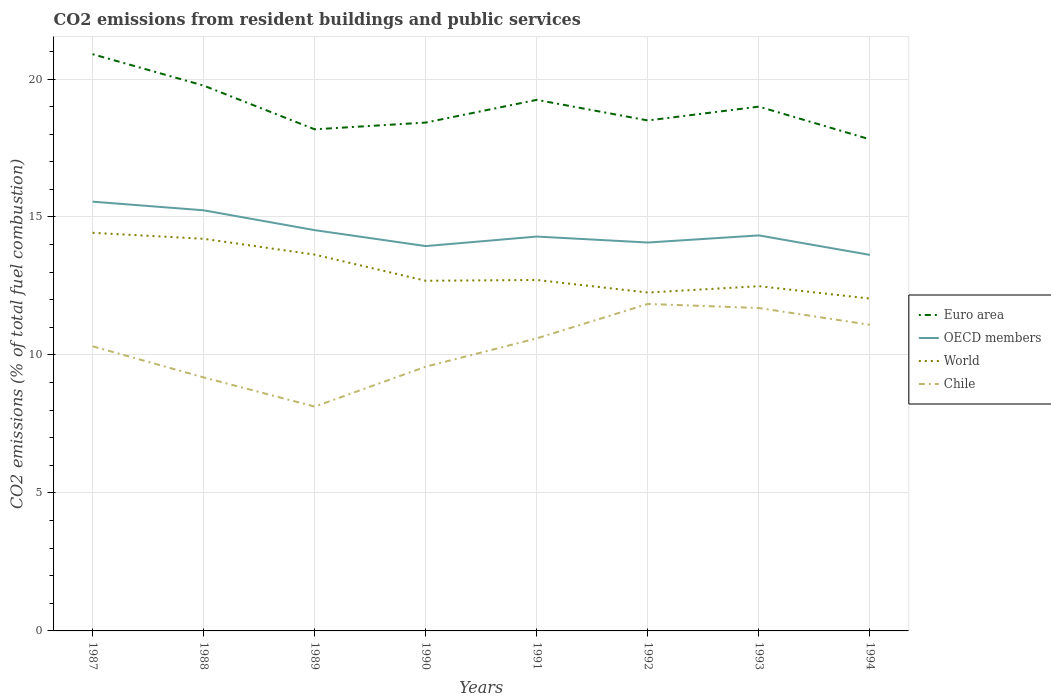How many different coloured lines are there?
Offer a terse response. 4. Does the line corresponding to Chile intersect with the line corresponding to Euro area?
Keep it short and to the point. No. Is the number of lines equal to the number of legend labels?
Your response must be concise. Yes. Across all years, what is the maximum total CO2 emitted in Euro area?
Your answer should be very brief. 17.81. What is the total total CO2 emitted in OECD members in the graph?
Offer a very short reply. -0.39. What is the difference between the highest and the second highest total CO2 emitted in World?
Provide a short and direct response. 2.38. Is the total CO2 emitted in World strictly greater than the total CO2 emitted in Euro area over the years?
Offer a terse response. Yes. How many lines are there?
Give a very brief answer. 4. How many years are there in the graph?
Ensure brevity in your answer.  8. What is the difference between two consecutive major ticks on the Y-axis?
Keep it short and to the point. 5. How many legend labels are there?
Your answer should be very brief. 4. How are the legend labels stacked?
Ensure brevity in your answer.  Vertical. What is the title of the graph?
Offer a very short reply. CO2 emissions from resident buildings and public services. What is the label or title of the X-axis?
Give a very brief answer. Years. What is the label or title of the Y-axis?
Keep it short and to the point. CO2 emissions (% of total fuel combustion). What is the CO2 emissions (% of total fuel combustion) in Euro area in 1987?
Provide a succinct answer. 20.9. What is the CO2 emissions (% of total fuel combustion) of OECD members in 1987?
Provide a short and direct response. 15.56. What is the CO2 emissions (% of total fuel combustion) in World in 1987?
Your answer should be very brief. 14.43. What is the CO2 emissions (% of total fuel combustion) of Chile in 1987?
Your response must be concise. 10.31. What is the CO2 emissions (% of total fuel combustion) in Euro area in 1988?
Provide a succinct answer. 19.76. What is the CO2 emissions (% of total fuel combustion) in OECD members in 1988?
Your answer should be very brief. 15.24. What is the CO2 emissions (% of total fuel combustion) in World in 1988?
Your response must be concise. 14.21. What is the CO2 emissions (% of total fuel combustion) of Chile in 1988?
Keep it short and to the point. 9.19. What is the CO2 emissions (% of total fuel combustion) in Euro area in 1989?
Make the answer very short. 18.18. What is the CO2 emissions (% of total fuel combustion) of OECD members in 1989?
Ensure brevity in your answer.  14.52. What is the CO2 emissions (% of total fuel combustion) in World in 1989?
Keep it short and to the point. 13.64. What is the CO2 emissions (% of total fuel combustion) of Chile in 1989?
Provide a succinct answer. 8.13. What is the CO2 emissions (% of total fuel combustion) in Euro area in 1990?
Provide a short and direct response. 18.42. What is the CO2 emissions (% of total fuel combustion) of OECD members in 1990?
Give a very brief answer. 13.95. What is the CO2 emissions (% of total fuel combustion) of World in 1990?
Your response must be concise. 12.69. What is the CO2 emissions (% of total fuel combustion) in Chile in 1990?
Offer a terse response. 9.57. What is the CO2 emissions (% of total fuel combustion) in Euro area in 1991?
Give a very brief answer. 19.24. What is the CO2 emissions (% of total fuel combustion) in OECD members in 1991?
Keep it short and to the point. 14.29. What is the CO2 emissions (% of total fuel combustion) of World in 1991?
Provide a succinct answer. 12.72. What is the CO2 emissions (% of total fuel combustion) in Chile in 1991?
Ensure brevity in your answer.  10.6. What is the CO2 emissions (% of total fuel combustion) in Euro area in 1992?
Provide a succinct answer. 18.5. What is the CO2 emissions (% of total fuel combustion) in OECD members in 1992?
Your answer should be compact. 14.07. What is the CO2 emissions (% of total fuel combustion) of World in 1992?
Your answer should be compact. 12.26. What is the CO2 emissions (% of total fuel combustion) in Chile in 1992?
Offer a terse response. 11.85. What is the CO2 emissions (% of total fuel combustion) in Euro area in 1993?
Ensure brevity in your answer.  19. What is the CO2 emissions (% of total fuel combustion) in OECD members in 1993?
Provide a succinct answer. 14.33. What is the CO2 emissions (% of total fuel combustion) of World in 1993?
Offer a terse response. 12.49. What is the CO2 emissions (% of total fuel combustion) in Chile in 1993?
Provide a short and direct response. 11.7. What is the CO2 emissions (% of total fuel combustion) in Euro area in 1994?
Give a very brief answer. 17.81. What is the CO2 emissions (% of total fuel combustion) of OECD members in 1994?
Your answer should be very brief. 13.63. What is the CO2 emissions (% of total fuel combustion) in World in 1994?
Provide a succinct answer. 12.04. What is the CO2 emissions (% of total fuel combustion) in Chile in 1994?
Make the answer very short. 11.09. Across all years, what is the maximum CO2 emissions (% of total fuel combustion) in Euro area?
Provide a succinct answer. 20.9. Across all years, what is the maximum CO2 emissions (% of total fuel combustion) of OECD members?
Provide a succinct answer. 15.56. Across all years, what is the maximum CO2 emissions (% of total fuel combustion) in World?
Provide a succinct answer. 14.43. Across all years, what is the maximum CO2 emissions (% of total fuel combustion) in Chile?
Ensure brevity in your answer.  11.85. Across all years, what is the minimum CO2 emissions (% of total fuel combustion) in Euro area?
Offer a very short reply. 17.81. Across all years, what is the minimum CO2 emissions (% of total fuel combustion) of OECD members?
Offer a very short reply. 13.63. Across all years, what is the minimum CO2 emissions (% of total fuel combustion) of World?
Provide a short and direct response. 12.04. Across all years, what is the minimum CO2 emissions (% of total fuel combustion) of Chile?
Your response must be concise. 8.13. What is the total CO2 emissions (% of total fuel combustion) in Euro area in the graph?
Give a very brief answer. 151.81. What is the total CO2 emissions (% of total fuel combustion) of OECD members in the graph?
Your response must be concise. 115.59. What is the total CO2 emissions (% of total fuel combustion) in World in the graph?
Ensure brevity in your answer.  104.48. What is the total CO2 emissions (% of total fuel combustion) in Chile in the graph?
Keep it short and to the point. 82.45. What is the difference between the CO2 emissions (% of total fuel combustion) in Euro area in 1987 and that in 1988?
Offer a very short reply. 1.14. What is the difference between the CO2 emissions (% of total fuel combustion) of OECD members in 1987 and that in 1988?
Offer a very short reply. 0.31. What is the difference between the CO2 emissions (% of total fuel combustion) in World in 1987 and that in 1988?
Provide a succinct answer. 0.22. What is the difference between the CO2 emissions (% of total fuel combustion) in Chile in 1987 and that in 1988?
Offer a very short reply. 1.13. What is the difference between the CO2 emissions (% of total fuel combustion) in Euro area in 1987 and that in 1989?
Your answer should be very brief. 2.72. What is the difference between the CO2 emissions (% of total fuel combustion) in OECD members in 1987 and that in 1989?
Give a very brief answer. 1.03. What is the difference between the CO2 emissions (% of total fuel combustion) in World in 1987 and that in 1989?
Keep it short and to the point. 0.79. What is the difference between the CO2 emissions (% of total fuel combustion) of Chile in 1987 and that in 1989?
Provide a short and direct response. 2.19. What is the difference between the CO2 emissions (% of total fuel combustion) in Euro area in 1987 and that in 1990?
Your answer should be very brief. 2.48. What is the difference between the CO2 emissions (% of total fuel combustion) of OECD members in 1987 and that in 1990?
Offer a very short reply. 1.61. What is the difference between the CO2 emissions (% of total fuel combustion) in World in 1987 and that in 1990?
Your response must be concise. 1.74. What is the difference between the CO2 emissions (% of total fuel combustion) of Chile in 1987 and that in 1990?
Your response must be concise. 0.74. What is the difference between the CO2 emissions (% of total fuel combustion) in Euro area in 1987 and that in 1991?
Your response must be concise. 1.65. What is the difference between the CO2 emissions (% of total fuel combustion) of OECD members in 1987 and that in 1991?
Provide a succinct answer. 1.26. What is the difference between the CO2 emissions (% of total fuel combustion) in World in 1987 and that in 1991?
Your response must be concise. 1.71. What is the difference between the CO2 emissions (% of total fuel combustion) of Chile in 1987 and that in 1991?
Your answer should be compact. -0.29. What is the difference between the CO2 emissions (% of total fuel combustion) of Euro area in 1987 and that in 1992?
Give a very brief answer. 2.4. What is the difference between the CO2 emissions (% of total fuel combustion) of OECD members in 1987 and that in 1992?
Ensure brevity in your answer.  1.48. What is the difference between the CO2 emissions (% of total fuel combustion) of World in 1987 and that in 1992?
Provide a short and direct response. 2.16. What is the difference between the CO2 emissions (% of total fuel combustion) of Chile in 1987 and that in 1992?
Make the answer very short. -1.53. What is the difference between the CO2 emissions (% of total fuel combustion) in Euro area in 1987 and that in 1993?
Provide a short and direct response. 1.9. What is the difference between the CO2 emissions (% of total fuel combustion) in OECD members in 1987 and that in 1993?
Offer a very short reply. 1.22. What is the difference between the CO2 emissions (% of total fuel combustion) of World in 1987 and that in 1993?
Your response must be concise. 1.93. What is the difference between the CO2 emissions (% of total fuel combustion) of Chile in 1987 and that in 1993?
Your response must be concise. -1.39. What is the difference between the CO2 emissions (% of total fuel combustion) of Euro area in 1987 and that in 1994?
Ensure brevity in your answer.  3.09. What is the difference between the CO2 emissions (% of total fuel combustion) in OECD members in 1987 and that in 1994?
Keep it short and to the point. 1.93. What is the difference between the CO2 emissions (% of total fuel combustion) in World in 1987 and that in 1994?
Ensure brevity in your answer.  2.38. What is the difference between the CO2 emissions (% of total fuel combustion) of Chile in 1987 and that in 1994?
Your answer should be very brief. -0.78. What is the difference between the CO2 emissions (% of total fuel combustion) in Euro area in 1988 and that in 1989?
Give a very brief answer. 1.58. What is the difference between the CO2 emissions (% of total fuel combustion) of OECD members in 1988 and that in 1989?
Provide a succinct answer. 0.72. What is the difference between the CO2 emissions (% of total fuel combustion) of World in 1988 and that in 1989?
Your response must be concise. 0.57. What is the difference between the CO2 emissions (% of total fuel combustion) in Chile in 1988 and that in 1989?
Your response must be concise. 1.06. What is the difference between the CO2 emissions (% of total fuel combustion) of Euro area in 1988 and that in 1990?
Keep it short and to the point. 1.34. What is the difference between the CO2 emissions (% of total fuel combustion) of OECD members in 1988 and that in 1990?
Your answer should be very brief. 1.3. What is the difference between the CO2 emissions (% of total fuel combustion) in World in 1988 and that in 1990?
Give a very brief answer. 1.52. What is the difference between the CO2 emissions (% of total fuel combustion) in Chile in 1988 and that in 1990?
Your answer should be very brief. -0.39. What is the difference between the CO2 emissions (% of total fuel combustion) of Euro area in 1988 and that in 1991?
Offer a very short reply. 0.52. What is the difference between the CO2 emissions (% of total fuel combustion) of OECD members in 1988 and that in 1991?
Make the answer very short. 0.95. What is the difference between the CO2 emissions (% of total fuel combustion) of World in 1988 and that in 1991?
Make the answer very short. 1.49. What is the difference between the CO2 emissions (% of total fuel combustion) of Chile in 1988 and that in 1991?
Provide a succinct answer. -1.42. What is the difference between the CO2 emissions (% of total fuel combustion) of Euro area in 1988 and that in 1992?
Your answer should be compact. 1.26. What is the difference between the CO2 emissions (% of total fuel combustion) of OECD members in 1988 and that in 1992?
Provide a short and direct response. 1.17. What is the difference between the CO2 emissions (% of total fuel combustion) of World in 1988 and that in 1992?
Your answer should be compact. 1.95. What is the difference between the CO2 emissions (% of total fuel combustion) in Chile in 1988 and that in 1992?
Give a very brief answer. -2.66. What is the difference between the CO2 emissions (% of total fuel combustion) of Euro area in 1988 and that in 1993?
Your answer should be very brief. 0.76. What is the difference between the CO2 emissions (% of total fuel combustion) in OECD members in 1988 and that in 1993?
Your response must be concise. 0.91. What is the difference between the CO2 emissions (% of total fuel combustion) of World in 1988 and that in 1993?
Your response must be concise. 1.72. What is the difference between the CO2 emissions (% of total fuel combustion) in Chile in 1988 and that in 1993?
Your answer should be very brief. -2.51. What is the difference between the CO2 emissions (% of total fuel combustion) in Euro area in 1988 and that in 1994?
Offer a very short reply. 1.95. What is the difference between the CO2 emissions (% of total fuel combustion) of OECD members in 1988 and that in 1994?
Your answer should be very brief. 1.62. What is the difference between the CO2 emissions (% of total fuel combustion) of World in 1988 and that in 1994?
Your answer should be compact. 2.17. What is the difference between the CO2 emissions (% of total fuel combustion) in Chile in 1988 and that in 1994?
Your response must be concise. -1.91. What is the difference between the CO2 emissions (% of total fuel combustion) in Euro area in 1989 and that in 1990?
Your answer should be very brief. -0.24. What is the difference between the CO2 emissions (% of total fuel combustion) of OECD members in 1989 and that in 1990?
Make the answer very short. 0.58. What is the difference between the CO2 emissions (% of total fuel combustion) of World in 1989 and that in 1990?
Provide a succinct answer. 0.95. What is the difference between the CO2 emissions (% of total fuel combustion) of Chile in 1989 and that in 1990?
Your answer should be compact. -1.45. What is the difference between the CO2 emissions (% of total fuel combustion) of Euro area in 1989 and that in 1991?
Ensure brevity in your answer.  -1.07. What is the difference between the CO2 emissions (% of total fuel combustion) of OECD members in 1989 and that in 1991?
Make the answer very short. 0.23. What is the difference between the CO2 emissions (% of total fuel combustion) of World in 1989 and that in 1991?
Your response must be concise. 0.92. What is the difference between the CO2 emissions (% of total fuel combustion) of Chile in 1989 and that in 1991?
Provide a short and direct response. -2.47. What is the difference between the CO2 emissions (% of total fuel combustion) of Euro area in 1989 and that in 1992?
Your answer should be very brief. -0.32. What is the difference between the CO2 emissions (% of total fuel combustion) of OECD members in 1989 and that in 1992?
Your response must be concise. 0.45. What is the difference between the CO2 emissions (% of total fuel combustion) in World in 1989 and that in 1992?
Give a very brief answer. 1.37. What is the difference between the CO2 emissions (% of total fuel combustion) in Chile in 1989 and that in 1992?
Provide a succinct answer. -3.72. What is the difference between the CO2 emissions (% of total fuel combustion) of Euro area in 1989 and that in 1993?
Provide a succinct answer. -0.82. What is the difference between the CO2 emissions (% of total fuel combustion) of OECD members in 1989 and that in 1993?
Offer a terse response. 0.19. What is the difference between the CO2 emissions (% of total fuel combustion) in World in 1989 and that in 1993?
Your answer should be compact. 1.14. What is the difference between the CO2 emissions (% of total fuel combustion) in Chile in 1989 and that in 1993?
Provide a succinct answer. -3.57. What is the difference between the CO2 emissions (% of total fuel combustion) of Euro area in 1989 and that in 1994?
Your response must be concise. 0.36. What is the difference between the CO2 emissions (% of total fuel combustion) in OECD members in 1989 and that in 1994?
Provide a succinct answer. 0.9. What is the difference between the CO2 emissions (% of total fuel combustion) in World in 1989 and that in 1994?
Keep it short and to the point. 1.59. What is the difference between the CO2 emissions (% of total fuel combustion) in Chile in 1989 and that in 1994?
Offer a very short reply. -2.96. What is the difference between the CO2 emissions (% of total fuel combustion) in Euro area in 1990 and that in 1991?
Provide a succinct answer. -0.82. What is the difference between the CO2 emissions (% of total fuel combustion) in OECD members in 1990 and that in 1991?
Provide a succinct answer. -0.35. What is the difference between the CO2 emissions (% of total fuel combustion) in World in 1990 and that in 1991?
Offer a terse response. -0.03. What is the difference between the CO2 emissions (% of total fuel combustion) in Chile in 1990 and that in 1991?
Ensure brevity in your answer.  -1.03. What is the difference between the CO2 emissions (% of total fuel combustion) of Euro area in 1990 and that in 1992?
Your answer should be very brief. -0.08. What is the difference between the CO2 emissions (% of total fuel combustion) of OECD members in 1990 and that in 1992?
Ensure brevity in your answer.  -0.13. What is the difference between the CO2 emissions (% of total fuel combustion) in World in 1990 and that in 1992?
Ensure brevity in your answer.  0.43. What is the difference between the CO2 emissions (% of total fuel combustion) in Chile in 1990 and that in 1992?
Keep it short and to the point. -2.27. What is the difference between the CO2 emissions (% of total fuel combustion) of Euro area in 1990 and that in 1993?
Offer a terse response. -0.58. What is the difference between the CO2 emissions (% of total fuel combustion) in OECD members in 1990 and that in 1993?
Ensure brevity in your answer.  -0.39. What is the difference between the CO2 emissions (% of total fuel combustion) in World in 1990 and that in 1993?
Provide a short and direct response. 0.2. What is the difference between the CO2 emissions (% of total fuel combustion) in Chile in 1990 and that in 1993?
Provide a succinct answer. -2.13. What is the difference between the CO2 emissions (% of total fuel combustion) in Euro area in 1990 and that in 1994?
Ensure brevity in your answer.  0.61. What is the difference between the CO2 emissions (% of total fuel combustion) of OECD members in 1990 and that in 1994?
Provide a short and direct response. 0.32. What is the difference between the CO2 emissions (% of total fuel combustion) of World in 1990 and that in 1994?
Your answer should be very brief. 0.64. What is the difference between the CO2 emissions (% of total fuel combustion) in Chile in 1990 and that in 1994?
Offer a terse response. -1.52. What is the difference between the CO2 emissions (% of total fuel combustion) of Euro area in 1991 and that in 1992?
Your response must be concise. 0.75. What is the difference between the CO2 emissions (% of total fuel combustion) in OECD members in 1991 and that in 1992?
Give a very brief answer. 0.22. What is the difference between the CO2 emissions (% of total fuel combustion) of World in 1991 and that in 1992?
Offer a terse response. 0.45. What is the difference between the CO2 emissions (% of total fuel combustion) of Chile in 1991 and that in 1992?
Keep it short and to the point. -1.25. What is the difference between the CO2 emissions (% of total fuel combustion) of Euro area in 1991 and that in 1993?
Keep it short and to the point. 0.24. What is the difference between the CO2 emissions (% of total fuel combustion) in OECD members in 1991 and that in 1993?
Offer a very short reply. -0.04. What is the difference between the CO2 emissions (% of total fuel combustion) in World in 1991 and that in 1993?
Provide a succinct answer. 0.23. What is the difference between the CO2 emissions (% of total fuel combustion) of Chile in 1991 and that in 1993?
Provide a short and direct response. -1.1. What is the difference between the CO2 emissions (% of total fuel combustion) of Euro area in 1991 and that in 1994?
Give a very brief answer. 1.43. What is the difference between the CO2 emissions (% of total fuel combustion) of OECD members in 1991 and that in 1994?
Make the answer very short. 0.66. What is the difference between the CO2 emissions (% of total fuel combustion) of World in 1991 and that in 1994?
Offer a terse response. 0.67. What is the difference between the CO2 emissions (% of total fuel combustion) in Chile in 1991 and that in 1994?
Your answer should be very brief. -0.49. What is the difference between the CO2 emissions (% of total fuel combustion) in Euro area in 1992 and that in 1993?
Offer a very short reply. -0.5. What is the difference between the CO2 emissions (% of total fuel combustion) of OECD members in 1992 and that in 1993?
Your response must be concise. -0.26. What is the difference between the CO2 emissions (% of total fuel combustion) in World in 1992 and that in 1993?
Your answer should be compact. -0.23. What is the difference between the CO2 emissions (% of total fuel combustion) of Chile in 1992 and that in 1993?
Your response must be concise. 0.15. What is the difference between the CO2 emissions (% of total fuel combustion) of Euro area in 1992 and that in 1994?
Make the answer very short. 0.68. What is the difference between the CO2 emissions (% of total fuel combustion) of OECD members in 1992 and that in 1994?
Keep it short and to the point. 0.45. What is the difference between the CO2 emissions (% of total fuel combustion) of World in 1992 and that in 1994?
Your response must be concise. 0.22. What is the difference between the CO2 emissions (% of total fuel combustion) in Chile in 1992 and that in 1994?
Provide a short and direct response. 0.76. What is the difference between the CO2 emissions (% of total fuel combustion) in Euro area in 1993 and that in 1994?
Offer a terse response. 1.19. What is the difference between the CO2 emissions (% of total fuel combustion) in OECD members in 1993 and that in 1994?
Provide a succinct answer. 0.71. What is the difference between the CO2 emissions (% of total fuel combustion) of World in 1993 and that in 1994?
Ensure brevity in your answer.  0.45. What is the difference between the CO2 emissions (% of total fuel combustion) of Chile in 1993 and that in 1994?
Your response must be concise. 0.61. What is the difference between the CO2 emissions (% of total fuel combustion) in Euro area in 1987 and the CO2 emissions (% of total fuel combustion) in OECD members in 1988?
Provide a short and direct response. 5.66. What is the difference between the CO2 emissions (% of total fuel combustion) in Euro area in 1987 and the CO2 emissions (% of total fuel combustion) in World in 1988?
Give a very brief answer. 6.69. What is the difference between the CO2 emissions (% of total fuel combustion) in Euro area in 1987 and the CO2 emissions (% of total fuel combustion) in Chile in 1988?
Your response must be concise. 11.71. What is the difference between the CO2 emissions (% of total fuel combustion) of OECD members in 1987 and the CO2 emissions (% of total fuel combustion) of World in 1988?
Offer a very short reply. 1.35. What is the difference between the CO2 emissions (% of total fuel combustion) of OECD members in 1987 and the CO2 emissions (% of total fuel combustion) of Chile in 1988?
Offer a very short reply. 6.37. What is the difference between the CO2 emissions (% of total fuel combustion) in World in 1987 and the CO2 emissions (% of total fuel combustion) in Chile in 1988?
Your response must be concise. 5.24. What is the difference between the CO2 emissions (% of total fuel combustion) of Euro area in 1987 and the CO2 emissions (% of total fuel combustion) of OECD members in 1989?
Keep it short and to the point. 6.38. What is the difference between the CO2 emissions (% of total fuel combustion) of Euro area in 1987 and the CO2 emissions (% of total fuel combustion) of World in 1989?
Ensure brevity in your answer.  7.26. What is the difference between the CO2 emissions (% of total fuel combustion) in Euro area in 1987 and the CO2 emissions (% of total fuel combustion) in Chile in 1989?
Keep it short and to the point. 12.77. What is the difference between the CO2 emissions (% of total fuel combustion) of OECD members in 1987 and the CO2 emissions (% of total fuel combustion) of World in 1989?
Offer a terse response. 1.92. What is the difference between the CO2 emissions (% of total fuel combustion) in OECD members in 1987 and the CO2 emissions (% of total fuel combustion) in Chile in 1989?
Provide a succinct answer. 7.43. What is the difference between the CO2 emissions (% of total fuel combustion) in World in 1987 and the CO2 emissions (% of total fuel combustion) in Chile in 1989?
Provide a short and direct response. 6.3. What is the difference between the CO2 emissions (% of total fuel combustion) in Euro area in 1987 and the CO2 emissions (% of total fuel combustion) in OECD members in 1990?
Give a very brief answer. 6.95. What is the difference between the CO2 emissions (% of total fuel combustion) of Euro area in 1987 and the CO2 emissions (% of total fuel combustion) of World in 1990?
Provide a succinct answer. 8.21. What is the difference between the CO2 emissions (% of total fuel combustion) of Euro area in 1987 and the CO2 emissions (% of total fuel combustion) of Chile in 1990?
Offer a terse response. 11.32. What is the difference between the CO2 emissions (% of total fuel combustion) of OECD members in 1987 and the CO2 emissions (% of total fuel combustion) of World in 1990?
Provide a succinct answer. 2.87. What is the difference between the CO2 emissions (% of total fuel combustion) in OECD members in 1987 and the CO2 emissions (% of total fuel combustion) in Chile in 1990?
Keep it short and to the point. 5.98. What is the difference between the CO2 emissions (% of total fuel combustion) of World in 1987 and the CO2 emissions (% of total fuel combustion) of Chile in 1990?
Your answer should be very brief. 4.85. What is the difference between the CO2 emissions (% of total fuel combustion) of Euro area in 1987 and the CO2 emissions (% of total fuel combustion) of OECD members in 1991?
Offer a terse response. 6.61. What is the difference between the CO2 emissions (% of total fuel combustion) in Euro area in 1987 and the CO2 emissions (% of total fuel combustion) in World in 1991?
Your answer should be compact. 8.18. What is the difference between the CO2 emissions (% of total fuel combustion) of Euro area in 1987 and the CO2 emissions (% of total fuel combustion) of Chile in 1991?
Provide a succinct answer. 10.3. What is the difference between the CO2 emissions (% of total fuel combustion) in OECD members in 1987 and the CO2 emissions (% of total fuel combustion) in World in 1991?
Your answer should be compact. 2.84. What is the difference between the CO2 emissions (% of total fuel combustion) of OECD members in 1987 and the CO2 emissions (% of total fuel combustion) of Chile in 1991?
Offer a very short reply. 4.95. What is the difference between the CO2 emissions (% of total fuel combustion) of World in 1987 and the CO2 emissions (% of total fuel combustion) of Chile in 1991?
Your response must be concise. 3.82. What is the difference between the CO2 emissions (% of total fuel combustion) in Euro area in 1987 and the CO2 emissions (% of total fuel combustion) in OECD members in 1992?
Offer a terse response. 6.82. What is the difference between the CO2 emissions (% of total fuel combustion) of Euro area in 1987 and the CO2 emissions (% of total fuel combustion) of World in 1992?
Ensure brevity in your answer.  8.64. What is the difference between the CO2 emissions (% of total fuel combustion) of Euro area in 1987 and the CO2 emissions (% of total fuel combustion) of Chile in 1992?
Your answer should be very brief. 9.05. What is the difference between the CO2 emissions (% of total fuel combustion) in OECD members in 1987 and the CO2 emissions (% of total fuel combustion) in World in 1992?
Your answer should be very brief. 3.29. What is the difference between the CO2 emissions (% of total fuel combustion) in OECD members in 1987 and the CO2 emissions (% of total fuel combustion) in Chile in 1992?
Ensure brevity in your answer.  3.71. What is the difference between the CO2 emissions (% of total fuel combustion) in World in 1987 and the CO2 emissions (% of total fuel combustion) in Chile in 1992?
Provide a succinct answer. 2.58. What is the difference between the CO2 emissions (% of total fuel combustion) in Euro area in 1987 and the CO2 emissions (% of total fuel combustion) in OECD members in 1993?
Your answer should be very brief. 6.57. What is the difference between the CO2 emissions (% of total fuel combustion) of Euro area in 1987 and the CO2 emissions (% of total fuel combustion) of World in 1993?
Provide a short and direct response. 8.41. What is the difference between the CO2 emissions (% of total fuel combustion) in Euro area in 1987 and the CO2 emissions (% of total fuel combustion) in Chile in 1993?
Make the answer very short. 9.2. What is the difference between the CO2 emissions (% of total fuel combustion) in OECD members in 1987 and the CO2 emissions (% of total fuel combustion) in World in 1993?
Provide a succinct answer. 3.06. What is the difference between the CO2 emissions (% of total fuel combustion) in OECD members in 1987 and the CO2 emissions (% of total fuel combustion) in Chile in 1993?
Your response must be concise. 3.85. What is the difference between the CO2 emissions (% of total fuel combustion) of World in 1987 and the CO2 emissions (% of total fuel combustion) of Chile in 1993?
Your answer should be very brief. 2.73. What is the difference between the CO2 emissions (% of total fuel combustion) of Euro area in 1987 and the CO2 emissions (% of total fuel combustion) of OECD members in 1994?
Make the answer very short. 7.27. What is the difference between the CO2 emissions (% of total fuel combustion) of Euro area in 1987 and the CO2 emissions (% of total fuel combustion) of World in 1994?
Your answer should be compact. 8.86. What is the difference between the CO2 emissions (% of total fuel combustion) of Euro area in 1987 and the CO2 emissions (% of total fuel combustion) of Chile in 1994?
Give a very brief answer. 9.81. What is the difference between the CO2 emissions (% of total fuel combustion) in OECD members in 1987 and the CO2 emissions (% of total fuel combustion) in World in 1994?
Your answer should be compact. 3.51. What is the difference between the CO2 emissions (% of total fuel combustion) in OECD members in 1987 and the CO2 emissions (% of total fuel combustion) in Chile in 1994?
Your answer should be very brief. 4.46. What is the difference between the CO2 emissions (% of total fuel combustion) in World in 1987 and the CO2 emissions (% of total fuel combustion) in Chile in 1994?
Offer a very short reply. 3.33. What is the difference between the CO2 emissions (% of total fuel combustion) of Euro area in 1988 and the CO2 emissions (% of total fuel combustion) of OECD members in 1989?
Provide a succinct answer. 5.24. What is the difference between the CO2 emissions (% of total fuel combustion) of Euro area in 1988 and the CO2 emissions (% of total fuel combustion) of World in 1989?
Provide a short and direct response. 6.13. What is the difference between the CO2 emissions (% of total fuel combustion) in Euro area in 1988 and the CO2 emissions (% of total fuel combustion) in Chile in 1989?
Keep it short and to the point. 11.63. What is the difference between the CO2 emissions (% of total fuel combustion) of OECD members in 1988 and the CO2 emissions (% of total fuel combustion) of World in 1989?
Provide a short and direct response. 1.61. What is the difference between the CO2 emissions (% of total fuel combustion) in OECD members in 1988 and the CO2 emissions (% of total fuel combustion) in Chile in 1989?
Provide a short and direct response. 7.11. What is the difference between the CO2 emissions (% of total fuel combustion) of World in 1988 and the CO2 emissions (% of total fuel combustion) of Chile in 1989?
Your response must be concise. 6.08. What is the difference between the CO2 emissions (% of total fuel combustion) of Euro area in 1988 and the CO2 emissions (% of total fuel combustion) of OECD members in 1990?
Offer a very short reply. 5.82. What is the difference between the CO2 emissions (% of total fuel combustion) of Euro area in 1988 and the CO2 emissions (% of total fuel combustion) of World in 1990?
Make the answer very short. 7.07. What is the difference between the CO2 emissions (% of total fuel combustion) in Euro area in 1988 and the CO2 emissions (% of total fuel combustion) in Chile in 1990?
Offer a terse response. 10.19. What is the difference between the CO2 emissions (% of total fuel combustion) in OECD members in 1988 and the CO2 emissions (% of total fuel combustion) in World in 1990?
Your answer should be compact. 2.55. What is the difference between the CO2 emissions (% of total fuel combustion) in OECD members in 1988 and the CO2 emissions (% of total fuel combustion) in Chile in 1990?
Make the answer very short. 5.67. What is the difference between the CO2 emissions (% of total fuel combustion) of World in 1988 and the CO2 emissions (% of total fuel combustion) of Chile in 1990?
Your answer should be compact. 4.63. What is the difference between the CO2 emissions (% of total fuel combustion) in Euro area in 1988 and the CO2 emissions (% of total fuel combustion) in OECD members in 1991?
Provide a succinct answer. 5.47. What is the difference between the CO2 emissions (% of total fuel combustion) of Euro area in 1988 and the CO2 emissions (% of total fuel combustion) of World in 1991?
Give a very brief answer. 7.04. What is the difference between the CO2 emissions (% of total fuel combustion) of Euro area in 1988 and the CO2 emissions (% of total fuel combustion) of Chile in 1991?
Your answer should be very brief. 9.16. What is the difference between the CO2 emissions (% of total fuel combustion) in OECD members in 1988 and the CO2 emissions (% of total fuel combustion) in World in 1991?
Provide a succinct answer. 2.52. What is the difference between the CO2 emissions (% of total fuel combustion) of OECD members in 1988 and the CO2 emissions (% of total fuel combustion) of Chile in 1991?
Your answer should be very brief. 4.64. What is the difference between the CO2 emissions (% of total fuel combustion) in World in 1988 and the CO2 emissions (% of total fuel combustion) in Chile in 1991?
Provide a succinct answer. 3.61. What is the difference between the CO2 emissions (% of total fuel combustion) of Euro area in 1988 and the CO2 emissions (% of total fuel combustion) of OECD members in 1992?
Your answer should be very brief. 5.69. What is the difference between the CO2 emissions (% of total fuel combustion) in Euro area in 1988 and the CO2 emissions (% of total fuel combustion) in World in 1992?
Offer a very short reply. 7.5. What is the difference between the CO2 emissions (% of total fuel combustion) of Euro area in 1988 and the CO2 emissions (% of total fuel combustion) of Chile in 1992?
Provide a succinct answer. 7.91. What is the difference between the CO2 emissions (% of total fuel combustion) of OECD members in 1988 and the CO2 emissions (% of total fuel combustion) of World in 1992?
Ensure brevity in your answer.  2.98. What is the difference between the CO2 emissions (% of total fuel combustion) of OECD members in 1988 and the CO2 emissions (% of total fuel combustion) of Chile in 1992?
Give a very brief answer. 3.39. What is the difference between the CO2 emissions (% of total fuel combustion) of World in 1988 and the CO2 emissions (% of total fuel combustion) of Chile in 1992?
Your answer should be compact. 2.36. What is the difference between the CO2 emissions (% of total fuel combustion) of Euro area in 1988 and the CO2 emissions (% of total fuel combustion) of OECD members in 1993?
Make the answer very short. 5.43. What is the difference between the CO2 emissions (% of total fuel combustion) in Euro area in 1988 and the CO2 emissions (% of total fuel combustion) in World in 1993?
Your answer should be very brief. 7.27. What is the difference between the CO2 emissions (% of total fuel combustion) in Euro area in 1988 and the CO2 emissions (% of total fuel combustion) in Chile in 1993?
Provide a succinct answer. 8.06. What is the difference between the CO2 emissions (% of total fuel combustion) in OECD members in 1988 and the CO2 emissions (% of total fuel combustion) in World in 1993?
Offer a very short reply. 2.75. What is the difference between the CO2 emissions (% of total fuel combustion) of OECD members in 1988 and the CO2 emissions (% of total fuel combustion) of Chile in 1993?
Make the answer very short. 3.54. What is the difference between the CO2 emissions (% of total fuel combustion) in World in 1988 and the CO2 emissions (% of total fuel combustion) in Chile in 1993?
Provide a short and direct response. 2.51. What is the difference between the CO2 emissions (% of total fuel combustion) of Euro area in 1988 and the CO2 emissions (% of total fuel combustion) of OECD members in 1994?
Keep it short and to the point. 6.14. What is the difference between the CO2 emissions (% of total fuel combustion) of Euro area in 1988 and the CO2 emissions (% of total fuel combustion) of World in 1994?
Keep it short and to the point. 7.72. What is the difference between the CO2 emissions (% of total fuel combustion) of Euro area in 1988 and the CO2 emissions (% of total fuel combustion) of Chile in 1994?
Make the answer very short. 8.67. What is the difference between the CO2 emissions (% of total fuel combustion) of OECD members in 1988 and the CO2 emissions (% of total fuel combustion) of World in 1994?
Your answer should be compact. 3.2. What is the difference between the CO2 emissions (% of total fuel combustion) in OECD members in 1988 and the CO2 emissions (% of total fuel combustion) in Chile in 1994?
Make the answer very short. 4.15. What is the difference between the CO2 emissions (% of total fuel combustion) of World in 1988 and the CO2 emissions (% of total fuel combustion) of Chile in 1994?
Keep it short and to the point. 3.12. What is the difference between the CO2 emissions (% of total fuel combustion) in Euro area in 1989 and the CO2 emissions (% of total fuel combustion) in OECD members in 1990?
Keep it short and to the point. 4.23. What is the difference between the CO2 emissions (% of total fuel combustion) in Euro area in 1989 and the CO2 emissions (% of total fuel combustion) in World in 1990?
Make the answer very short. 5.49. What is the difference between the CO2 emissions (% of total fuel combustion) of Euro area in 1989 and the CO2 emissions (% of total fuel combustion) of Chile in 1990?
Your response must be concise. 8.6. What is the difference between the CO2 emissions (% of total fuel combustion) in OECD members in 1989 and the CO2 emissions (% of total fuel combustion) in World in 1990?
Your answer should be compact. 1.83. What is the difference between the CO2 emissions (% of total fuel combustion) in OECD members in 1989 and the CO2 emissions (% of total fuel combustion) in Chile in 1990?
Ensure brevity in your answer.  4.95. What is the difference between the CO2 emissions (% of total fuel combustion) in World in 1989 and the CO2 emissions (% of total fuel combustion) in Chile in 1990?
Make the answer very short. 4.06. What is the difference between the CO2 emissions (% of total fuel combustion) in Euro area in 1989 and the CO2 emissions (% of total fuel combustion) in OECD members in 1991?
Ensure brevity in your answer.  3.89. What is the difference between the CO2 emissions (% of total fuel combustion) of Euro area in 1989 and the CO2 emissions (% of total fuel combustion) of World in 1991?
Your response must be concise. 5.46. What is the difference between the CO2 emissions (% of total fuel combustion) in Euro area in 1989 and the CO2 emissions (% of total fuel combustion) in Chile in 1991?
Provide a short and direct response. 7.57. What is the difference between the CO2 emissions (% of total fuel combustion) in OECD members in 1989 and the CO2 emissions (% of total fuel combustion) in World in 1991?
Your answer should be compact. 1.81. What is the difference between the CO2 emissions (% of total fuel combustion) of OECD members in 1989 and the CO2 emissions (% of total fuel combustion) of Chile in 1991?
Make the answer very short. 3.92. What is the difference between the CO2 emissions (% of total fuel combustion) in World in 1989 and the CO2 emissions (% of total fuel combustion) in Chile in 1991?
Offer a terse response. 3.03. What is the difference between the CO2 emissions (% of total fuel combustion) of Euro area in 1989 and the CO2 emissions (% of total fuel combustion) of OECD members in 1992?
Offer a very short reply. 4.1. What is the difference between the CO2 emissions (% of total fuel combustion) of Euro area in 1989 and the CO2 emissions (% of total fuel combustion) of World in 1992?
Offer a terse response. 5.91. What is the difference between the CO2 emissions (% of total fuel combustion) of Euro area in 1989 and the CO2 emissions (% of total fuel combustion) of Chile in 1992?
Make the answer very short. 6.33. What is the difference between the CO2 emissions (% of total fuel combustion) of OECD members in 1989 and the CO2 emissions (% of total fuel combustion) of World in 1992?
Give a very brief answer. 2.26. What is the difference between the CO2 emissions (% of total fuel combustion) of OECD members in 1989 and the CO2 emissions (% of total fuel combustion) of Chile in 1992?
Your response must be concise. 2.67. What is the difference between the CO2 emissions (% of total fuel combustion) in World in 1989 and the CO2 emissions (% of total fuel combustion) in Chile in 1992?
Give a very brief answer. 1.79. What is the difference between the CO2 emissions (% of total fuel combustion) of Euro area in 1989 and the CO2 emissions (% of total fuel combustion) of OECD members in 1993?
Keep it short and to the point. 3.84. What is the difference between the CO2 emissions (% of total fuel combustion) in Euro area in 1989 and the CO2 emissions (% of total fuel combustion) in World in 1993?
Your answer should be very brief. 5.68. What is the difference between the CO2 emissions (% of total fuel combustion) of Euro area in 1989 and the CO2 emissions (% of total fuel combustion) of Chile in 1993?
Your response must be concise. 6.48. What is the difference between the CO2 emissions (% of total fuel combustion) in OECD members in 1989 and the CO2 emissions (% of total fuel combustion) in World in 1993?
Ensure brevity in your answer.  2.03. What is the difference between the CO2 emissions (% of total fuel combustion) of OECD members in 1989 and the CO2 emissions (% of total fuel combustion) of Chile in 1993?
Offer a terse response. 2.82. What is the difference between the CO2 emissions (% of total fuel combustion) of World in 1989 and the CO2 emissions (% of total fuel combustion) of Chile in 1993?
Offer a very short reply. 1.93. What is the difference between the CO2 emissions (% of total fuel combustion) in Euro area in 1989 and the CO2 emissions (% of total fuel combustion) in OECD members in 1994?
Ensure brevity in your answer.  4.55. What is the difference between the CO2 emissions (% of total fuel combustion) in Euro area in 1989 and the CO2 emissions (% of total fuel combustion) in World in 1994?
Your answer should be compact. 6.13. What is the difference between the CO2 emissions (% of total fuel combustion) of Euro area in 1989 and the CO2 emissions (% of total fuel combustion) of Chile in 1994?
Provide a succinct answer. 7.08. What is the difference between the CO2 emissions (% of total fuel combustion) of OECD members in 1989 and the CO2 emissions (% of total fuel combustion) of World in 1994?
Make the answer very short. 2.48. What is the difference between the CO2 emissions (% of total fuel combustion) of OECD members in 1989 and the CO2 emissions (% of total fuel combustion) of Chile in 1994?
Give a very brief answer. 3.43. What is the difference between the CO2 emissions (% of total fuel combustion) in World in 1989 and the CO2 emissions (% of total fuel combustion) in Chile in 1994?
Offer a very short reply. 2.54. What is the difference between the CO2 emissions (% of total fuel combustion) of Euro area in 1990 and the CO2 emissions (% of total fuel combustion) of OECD members in 1991?
Keep it short and to the point. 4.13. What is the difference between the CO2 emissions (% of total fuel combustion) in Euro area in 1990 and the CO2 emissions (% of total fuel combustion) in World in 1991?
Keep it short and to the point. 5.7. What is the difference between the CO2 emissions (% of total fuel combustion) in Euro area in 1990 and the CO2 emissions (% of total fuel combustion) in Chile in 1991?
Make the answer very short. 7.82. What is the difference between the CO2 emissions (% of total fuel combustion) of OECD members in 1990 and the CO2 emissions (% of total fuel combustion) of World in 1991?
Give a very brief answer. 1.23. What is the difference between the CO2 emissions (% of total fuel combustion) in OECD members in 1990 and the CO2 emissions (% of total fuel combustion) in Chile in 1991?
Offer a terse response. 3.34. What is the difference between the CO2 emissions (% of total fuel combustion) of World in 1990 and the CO2 emissions (% of total fuel combustion) of Chile in 1991?
Provide a short and direct response. 2.09. What is the difference between the CO2 emissions (% of total fuel combustion) of Euro area in 1990 and the CO2 emissions (% of total fuel combustion) of OECD members in 1992?
Your response must be concise. 4.35. What is the difference between the CO2 emissions (% of total fuel combustion) in Euro area in 1990 and the CO2 emissions (% of total fuel combustion) in World in 1992?
Your answer should be very brief. 6.16. What is the difference between the CO2 emissions (% of total fuel combustion) in Euro area in 1990 and the CO2 emissions (% of total fuel combustion) in Chile in 1992?
Offer a terse response. 6.57. What is the difference between the CO2 emissions (% of total fuel combustion) in OECD members in 1990 and the CO2 emissions (% of total fuel combustion) in World in 1992?
Keep it short and to the point. 1.68. What is the difference between the CO2 emissions (% of total fuel combustion) of OECD members in 1990 and the CO2 emissions (% of total fuel combustion) of Chile in 1992?
Provide a short and direct response. 2.1. What is the difference between the CO2 emissions (% of total fuel combustion) of World in 1990 and the CO2 emissions (% of total fuel combustion) of Chile in 1992?
Provide a succinct answer. 0.84. What is the difference between the CO2 emissions (% of total fuel combustion) of Euro area in 1990 and the CO2 emissions (% of total fuel combustion) of OECD members in 1993?
Offer a very short reply. 4.09. What is the difference between the CO2 emissions (% of total fuel combustion) of Euro area in 1990 and the CO2 emissions (% of total fuel combustion) of World in 1993?
Your answer should be very brief. 5.93. What is the difference between the CO2 emissions (% of total fuel combustion) in Euro area in 1990 and the CO2 emissions (% of total fuel combustion) in Chile in 1993?
Offer a very short reply. 6.72. What is the difference between the CO2 emissions (% of total fuel combustion) of OECD members in 1990 and the CO2 emissions (% of total fuel combustion) of World in 1993?
Your response must be concise. 1.45. What is the difference between the CO2 emissions (% of total fuel combustion) in OECD members in 1990 and the CO2 emissions (% of total fuel combustion) in Chile in 1993?
Your answer should be very brief. 2.24. What is the difference between the CO2 emissions (% of total fuel combustion) of World in 1990 and the CO2 emissions (% of total fuel combustion) of Chile in 1993?
Your answer should be very brief. 0.99. What is the difference between the CO2 emissions (% of total fuel combustion) of Euro area in 1990 and the CO2 emissions (% of total fuel combustion) of OECD members in 1994?
Your answer should be very brief. 4.8. What is the difference between the CO2 emissions (% of total fuel combustion) in Euro area in 1990 and the CO2 emissions (% of total fuel combustion) in World in 1994?
Your answer should be very brief. 6.38. What is the difference between the CO2 emissions (% of total fuel combustion) of Euro area in 1990 and the CO2 emissions (% of total fuel combustion) of Chile in 1994?
Give a very brief answer. 7.33. What is the difference between the CO2 emissions (% of total fuel combustion) in OECD members in 1990 and the CO2 emissions (% of total fuel combustion) in World in 1994?
Offer a very short reply. 1.9. What is the difference between the CO2 emissions (% of total fuel combustion) of OECD members in 1990 and the CO2 emissions (% of total fuel combustion) of Chile in 1994?
Provide a succinct answer. 2.85. What is the difference between the CO2 emissions (% of total fuel combustion) of World in 1990 and the CO2 emissions (% of total fuel combustion) of Chile in 1994?
Offer a terse response. 1.6. What is the difference between the CO2 emissions (% of total fuel combustion) in Euro area in 1991 and the CO2 emissions (% of total fuel combustion) in OECD members in 1992?
Ensure brevity in your answer.  5.17. What is the difference between the CO2 emissions (% of total fuel combustion) in Euro area in 1991 and the CO2 emissions (% of total fuel combustion) in World in 1992?
Provide a succinct answer. 6.98. What is the difference between the CO2 emissions (% of total fuel combustion) in Euro area in 1991 and the CO2 emissions (% of total fuel combustion) in Chile in 1992?
Ensure brevity in your answer.  7.4. What is the difference between the CO2 emissions (% of total fuel combustion) in OECD members in 1991 and the CO2 emissions (% of total fuel combustion) in World in 1992?
Provide a short and direct response. 2.03. What is the difference between the CO2 emissions (% of total fuel combustion) of OECD members in 1991 and the CO2 emissions (% of total fuel combustion) of Chile in 1992?
Offer a very short reply. 2.44. What is the difference between the CO2 emissions (% of total fuel combustion) in World in 1991 and the CO2 emissions (% of total fuel combustion) in Chile in 1992?
Ensure brevity in your answer.  0.87. What is the difference between the CO2 emissions (% of total fuel combustion) in Euro area in 1991 and the CO2 emissions (% of total fuel combustion) in OECD members in 1993?
Ensure brevity in your answer.  4.91. What is the difference between the CO2 emissions (% of total fuel combustion) in Euro area in 1991 and the CO2 emissions (% of total fuel combustion) in World in 1993?
Offer a very short reply. 6.75. What is the difference between the CO2 emissions (% of total fuel combustion) of Euro area in 1991 and the CO2 emissions (% of total fuel combustion) of Chile in 1993?
Provide a short and direct response. 7.54. What is the difference between the CO2 emissions (% of total fuel combustion) of OECD members in 1991 and the CO2 emissions (% of total fuel combustion) of World in 1993?
Offer a terse response. 1.8. What is the difference between the CO2 emissions (% of total fuel combustion) in OECD members in 1991 and the CO2 emissions (% of total fuel combustion) in Chile in 1993?
Keep it short and to the point. 2.59. What is the difference between the CO2 emissions (% of total fuel combustion) in World in 1991 and the CO2 emissions (% of total fuel combustion) in Chile in 1993?
Provide a succinct answer. 1.02. What is the difference between the CO2 emissions (% of total fuel combustion) in Euro area in 1991 and the CO2 emissions (% of total fuel combustion) in OECD members in 1994?
Ensure brevity in your answer.  5.62. What is the difference between the CO2 emissions (% of total fuel combustion) of Euro area in 1991 and the CO2 emissions (% of total fuel combustion) of World in 1994?
Offer a terse response. 7.2. What is the difference between the CO2 emissions (% of total fuel combustion) of Euro area in 1991 and the CO2 emissions (% of total fuel combustion) of Chile in 1994?
Give a very brief answer. 8.15. What is the difference between the CO2 emissions (% of total fuel combustion) in OECD members in 1991 and the CO2 emissions (% of total fuel combustion) in World in 1994?
Provide a succinct answer. 2.25. What is the difference between the CO2 emissions (% of total fuel combustion) in OECD members in 1991 and the CO2 emissions (% of total fuel combustion) in Chile in 1994?
Offer a terse response. 3.2. What is the difference between the CO2 emissions (% of total fuel combustion) in World in 1991 and the CO2 emissions (% of total fuel combustion) in Chile in 1994?
Provide a succinct answer. 1.62. What is the difference between the CO2 emissions (% of total fuel combustion) in Euro area in 1992 and the CO2 emissions (% of total fuel combustion) in OECD members in 1993?
Give a very brief answer. 4.16. What is the difference between the CO2 emissions (% of total fuel combustion) in Euro area in 1992 and the CO2 emissions (% of total fuel combustion) in World in 1993?
Offer a terse response. 6.01. What is the difference between the CO2 emissions (% of total fuel combustion) in Euro area in 1992 and the CO2 emissions (% of total fuel combustion) in Chile in 1993?
Make the answer very short. 6.8. What is the difference between the CO2 emissions (% of total fuel combustion) in OECD members in 1992 and the CO2 emissions (% of total fuel combustion) in World in 1993?
Provide a succinct answer. 1.58. What is the difference between the CO2 emissions (% of total fuel combustion) in OECD members in 1992 and the CO2 emissions (% of total fuel combustion) in Chile in 1993?
Your answer should be compact. 2.37. What is the difference between the CO2 emissions (% of total fuel combustion) of World in 1992 and the CO2 emissions (% of total fuel combustion) of Chile in 1993?
Ensure brevity in your answer.  0.56. What is the difference between the CO2 emissions (% of total fuel combustion) in Euro area in 1992 and the CO2 emissions (% of total fuel combustion) in OECD members in 1994?
Your answer should be compact. 4.87. What is the difference between the CO2 emissions (% of total fuel combustion) in Euro area in 1992 and the CO2 emissions (% of total fuel combustion) in World in 1994?
Your response must be concise. 6.45. What is the difference between the CO2 emissions (% of total fuel combustion) of Euro area in 1992 and the CO2 emissions (% of total fuel combustion) of Chile in 1994?
Make the answer very short. 7.4. What is the difference between the CO2 emissions (% of total fuel combustion) of OECD members in 1992 and the CO2 emissions (% of total fuel combustion) of World in 1994?
Ensure brevity in your answer.  2.03. What is the difference between the CO2 emissions (% of total fuel combustion) of OECD members in 1992 and the CO2 emissions (% of total fuel combustion) of Chile in 1994?
Provide a succinct answer. 2.98. What is the difference between the CO2 emissions (% of total fuel combustion) of World in 1992 and the CO2 emissions (% of total fuel combustion) of Chile in 1994?
Offer a very short reply. 1.17. What is the difference between the CO2 emissions (% of total fuel combustion) of Euro area in 1993 and the CO2 emissions (% of total fuel combustion) of OECD members in 1994?
Provide a short and direct response. 5.37. What is the difference between the CO2 emissions (% of total fuel combustion) of Euro area in 1993 and the CO2 emissions (% of total fuel combustion) of World in 1994?
Keep it short and to the point. 6.96. What is the difference between the CO2 emissions (% of total fuel combustion) in Euro area in 1993 and the CO2 emissions (% of total fuel combustion) in Chile in 1994?
Your response must be concise. 7.91. What is the difference between the CO2 emissions (% of total fuel combustion) in OECD members in 1993 and the CO2 emissions (% of total fuel combustion) in World in 1994?
Your response must be concise. 2.29. What is the difference between the CO2 emissions (% of total fuel combustion) of OECD members in 1993 and the CO2 emissions (% of total fuel combustion) of Chile in 1994?
Provide a short and direct response. 3.24. What is the difference between the CO2 emissions (% of total fuel combustion) in World in 1993 and the CO2 emissions (% of total fuel combustion) in Chile in 1994?
Ensure brevity in your answer.  1.4. What is the average CO2 emissions (% of total fuel combustion) of Euro area per year?
Your response must be concise. 18.98. What is the average CO2 emissions (% of total fuel combustion) of OECD members per year?
Your answer should be compact. 14.45. What is the average CO2 emissions (% of total fuel combustion) of World per year?
Your answer should be very brief. 13.06. What is the average CO2 emissions (% of total fuel combustion) of Chile per year?
Your answer should be very brief. 10.31. In the year 1987, what is the difference between the CO2 emissions (% of total fuel combustion) in Euro area and CO2 emissions (% of total fuel combustion) in OECD members?
Provide a short and direct response. 5.34. In the year 1987, what is the difference between the CO2 emissions (% of total fuel combustion) in Euro area and CO2 emissions (% of total fuel combustion) in World?
Your answer should be compact. 6.47. In the year 1987, what is the difference between the CO2 emissions (% of total fuel combustion) in Euro area and CO2 emissions (% of total fuel combustion) in Chile?
Keep it short and to the point. 10.58. In the year 1987, what is the difference between the CO2 emissions (% of total fuel combustion) of OECD members and CO2 emissions (% of total fuel combustion) of World?
Ensure brevity in your answer.  1.13. In the year 1987, what is the difference between the CO2 emissions (% of total fuel combustion) of OECD members and CO2 emissions (% of total fuel combustion) of Chile?
Offer a terse response. 5.24. In the year 1987, what is the difference between the CO2 emissions (% of total fuel combustion) in World and CO2 emissions (% of total fuel combustion) in Chile?
Offer a very short reply. 4.11. In the year 1988, what is the difference between the CO2 emissions (% of total fuel combustion) in Euro area and CO2 emissions (% of total fuel combustion) in OECD members?
Offer a terse response. 4.52. In the year 1988, what is the difference between the CO2 emissions (% of total fuel combustion) in Euro area and CO2 emissions (% of total fuel combustion) in World?
Offer a terse response. 5.55. In the year 1988, what is the difference between the CO2 emissions (% of total fuel combustion) of Euro area and CO2 emissions (% of total fuel combustion) of Chile?
Ensure brevity in your answer.  10.57. In the year 1988, what is the difference between the CO2 emissions (% of total fuel combustion) of OECD members and CO2 emissions (% of total fuel combustion) of World?
Give a very brief answer. 1.03. In the year 1988, what is the difference between the CO2 emissions (% of total fuel combustion) of OECD members and CO2 emissions (% of total fuel combustion) of Chile?
Your response must be concise. 6.05. In the year 1988, what is the difference between the CO2 emissions (% of total fuel combustion) of World and CO2 emissions (% of total fuel combustion) of Chile?
Provide a short and direct response. 5.02. In the year 1989, what is the difference between the CO2 emissions (% of total fuel combustion) of Euro area and CO2 emissions (% of total fuel combustion) of OECD members?
Offer a very short reply. 3.65. In the year 1989, what is the difference between the CO2 emissions (% of total fuel combustion) in Euro area and CO2 emissions (% of total fuel combustion) in World?
Ensure brevity in your answer.  4.54. In the year 1989, what is the difference between the CO2 emissions (% of total fuel combustion) in Euro area and CO2 emissions (% of total fuel combustion) in Chile?
Keep it short and to the point. 10.05. In the year 1989, what is the difference between the CO2 emissions (% of total fuel combustion) of OECD members and CO2 emissions (% of total fuel combustion) of World?
Provide a short and direct response. 0.89. In the year 1989, what is the difference between the CO2 emissions (% of total fuel combustion) in OECD members and CO2 emissions (% of total fuel combustion) in Chile?
Ensure brevity in your answer.  6.39. In the year 1989, what is the difference between the CO2 emissions (% of total fuel combustion) in World and CO2 emissions (% of total fuel combustion) in Chile?
Your answer should be compact. 5.51. In the year 1990, what is the difference between the CO2 emissions (% of total fuel combustion) in Euro area and CO2 emissions (% of total fuel combustion) in OECD members?
Offer a very short reply. 4.48. In the year 1990, what is the difference between the CO2 emissions (% of total fuel combustion) in Euro area and CO2 emissions (% of total fuel combustion) in World?
Provide a short and direct response. 5.73. In the year 1990, what is the difference between the CO2 emissions (% of total fuel combustion) in Euro area and CO2 emissions (% of total fuel combustion) in Chile?
Provide a short and direct response. 8.85. In the year 1990, what is the difference between the CO2 emissions (% of total fuel combustion) in OECD members and CO2 emissions (% of total fuel combustion) in World?
Give a very brief answer. 1.26. In the year 1990, what is the difference between the CO2 emissions (% of total fuel combustion) in OECD members and CO2 emissions (% of total fuel combustion) in Chile?
Your answer should be very brief. 4.37. In the year 1990, what is the difference between the CO2 emissions (% of total fuel combustion) of World and CO2 emissions (% of total fuel combustion) of Chile?
Your response must be concise. 3.11. In the year 1991, what is the difference between the CO2 emissions (% of total fuel combustion) in Euro area and CO2 emissions (% of total fuel combustion) in OECD members?
Offer a terse response. 4.95. In the year 1991, what is the difference between the CO2 emissions (% of total fuel combustion) in Euro area and CO2 emissions (% of total fuel combustion) in World?
Offer a terse response. 6.53. In the year 1991, what is the difference between the CO2 emissions (% of total fuel combustion) in Euro area and CO2 emissions (% of total fuel combustion) in Chile?
Ensure brevity in your answer.  8.64. In the year 1991, what is the difference between the CO2 emissions (% of total fuel combustion) of OECD members and CO2 emissions (% of total fuel combustion) of World?
Offer a terse response. 1.57. In the year 1991, what is the difference between the CO2 emissions (% of total fuel combustion) of OECD members and CO2 emissions (% of total fuel combustion) of Chile?
Offer a very short reply. 3.69. In the year 1991, what is the difference between the CO2 emissions (% of total fuel combustion) of World and CO2 emissions (% of total fuel combustion) of Chile?
Make the answer very short. 2.11. In the year 1992, what is the difference between the CO2 emissions (% of total fuel combustion) of Euro area and CO2 emissions (% of total fuel combustion) of OECD members?
Make the answer very short. 4.42. In the year 1992, what is the difference between the CO2 emissions (% of total fuel combustion) in Euro area and CO2 emissions (% of total fuel combustion) in World?
Offer a terse response. 6.24. In the year 1992, what is the difference between the CO2 emissions (% of total fuel combustion) in Euro area and CO2 emissions (% of total fuel combustion) in Chile?
Ensure brevity in your answer.  6.65. In the year 1992, what is the difference between the CO2 emissions (% of total fuel combustion) in OECD members and CO2 emissions (% of total fuel combustion) in World?
Your answer should be compact. 1.81. In the year 1992, what is the difference between the CO2 emissions (% of total fuel combustion) of OECD members and CO2 emissions (% of total fuel combustion) of Chile?
Give a very brief answer. 2.23. In the year 1992, what is the difference between the CO2 emissions (% of total fuel combustion) of World and CO2 emissions (% of total fuel combustion) of Chile?
Give a very brief answer. 0.41. In the year 1993, what is the difference between the CO2 emissions (% of total fuel combustion) in Euro area and CO2 emissions (% of total fuel combustion) in OECD members?
Give a very brief answer. 4.67. In the year 1993, what is the difference between the CO2 emissions (% of total fuel combustion) of Euro area and CO2 emissions (% of total fuel combustion) of World?
Ensure brevity in your answer.  6.51. In the year 1993, what is the difference between the CO2 emissions (% of total fuel combustion) of Euro area and CO2 emissions (% of total fuel combustion) of Chile?
Offer a very short reply. 7.3. In the year 1993, what is the difference between the CO2 emissions (% of total fuel combustion) in OECD members and CO2 emissions (% of total fuel combustion) in World?
Your answer should be compact. 1.84. In the year 1993, what is the difference between the CO2 emissions (% of total fuel combustion) of OECD members and CO2 emissions (% of total fuel combustion) of Chile?
Your answer should be compact. 2.63. In the year 1993, what is the difference between the CO2 emissions (% of total fuel combustion) in World and CO2 emissions (% of total fuel combustion) in Chile?
Provide a short and direct response. 0.79. In the year 1994, what is the difference between the CO2 emissions (% of total fuel combustion) of Euro area and CO2 emissions (% of total fuel combustion) of OECD members?
Keep it short and to the point. 4.19. In the year 1994, what is the difference between the CO2 emissions (% of total fuel combustion) in Euro area and CO2 emissions (% of total fuel combustion) in World?
Keep it short and to the point. 5.77. In the year 1994, what is the difference between the CO2 emissions (% of total fuel combustion) in Euro area and CO2 emissions (% of total fuel combustion) in Chile?
Your answer should be very brief. 6.72. In the year 1994, what is the difference between the CO2 emissions (% of total fuel combustion) in OECD members and CO2 emissions (% of total fuel combustion) in World?
Offer a terse response. 1.58. In the year 1994, what is the difference between the CO2 emissions (% of total fuel combustion) of OECD members and CO2 emissions (% of total fuel combustion) of Chile?
Your response must be concise. 2.53. In the year 1994, what is the difference between the CO2 emissions (% of total fuel combustion) in World and CO2 emissions (% of total fuel combustion) in Chile?
Make the answer very short. 0.95. What is the ratio of the CO2 emissions (% of total fuel combustion) of Euro area in 1987 to that in 1988?
Your response must be concise. 1.06. What is the ratio of the CO2 emissions (% of total fuel combustion) in OECD members in 1987 to that in 1988?
Your answer should be very brief. 1.02. What is the ratio of the CO2 emissions (% of total fuel combustion) of World in 1987 to that in 1988?
Provide a short and direct response. 1.02. What is the ratio of the CO2 emissions (% of total fuel combustion) of Chile in 1987 to that in 1988?
Offer a terse response. 1.12. What is the ratio of the CO2 emissions (% of total fuel combustion) of Euro area in 1987 to that in 1989?
Offer a terse response. 1.15. What is the ratio of the CO2 emissions (% of total fuel combustion) of OECD members in 1987 to that in 1989?
Offer a terse response. 1.07. What is the ratio of the CO2 emissions (% of total fuel combustion) of World in 1987 to that in 1989?
Provide a short and direct response. 1.06. What is the ratio of the CO2 emissions (% of total fuel combustion) of Chile in 1987 to that in 1989?
Make the answer very short. 1.27. What is the ratio of the CO2 emissions (% of total fuel combustion) of Euro area in 1987 to that in 1990?
Ensure brevity in your answer.  1.13. What is the ratio of the CO2 emissions (% of total fuel combustion) in OECD members in 1987 to that in 1990?
Your response must be concise. 1.12. What is the ratio of the CO2 emissions (% of total fuel combustion) in World in 1987 to that in 1990?
Offer a terse response. 1.14. What is the ratio of the CO2 emissions (% of total fuel combustion) in Chile in 1987 to that in 1990?
Make the answer very short. 1.08. What is the ratio of the CO2 emissions (% of total fuel combustion) of Euro area in 1987 to that in 1991?
Provide a short and direct response. 1.09. What is the ratio of the CO2 emissions (% of total fuel combustion) of OECD members in 1987 to that in 1991?
Your answer should be very brief. 1.09. What is the ratio of the CO2 emissions (% of total fuel combustion) in World in 1987 to that in 1991?
Ensure brevity in your answer.  1.13. What is the ratio of the CO2 emissions (% of total fuel combustion) of Chile in 1987 to that in 1991?
Provide a succinct answer. 0.97. What is the ratio of the CO2 emissions (% of total fuel combustion) in Euro area in 1987 to that in 1992?
Offer a very short reply. 1.13. What is the ratio of the CO2 emissions (% of total fuel combustion) of OECD members in 1987 to that in 1992?
Provide a succinct answer. 1.11. What is the ratio of the CO2 emissions (% of total fuel combustion) of World in 1987 to that in 1992?
Provide a short and direct response. 1.18. What is the ratio of the CO2 emissions (% of total fuel combustion) in Chile in 1987 to that in 1992?
Your response must be concise. 0.87. What is the ratio of the CO2 emissions (% of total fuel combustion) in Euro area in 1987 to that in 1993?
Give a very brief answer. 1.1. What is the ratio of the CO2 emissions (% of total fuel combustion) of OECD members in 1987 to that in 1993?
Provide a short and direct response. 1.09. What is the ratio of the CO2 emissions (% of total fuel combustion) of World in 1987 to that in 1993?
Keep it short and to the point. 1.15. What is the ratio of the CO2 emissions (% of total fuel combustion) in Chile in 1987 to that in 1993?
Offer a very short reply. 0.88. What is the ratio of the CO2 emissions (% of total fuel combustion) in Euro area in 1987 to that in 1994?
Provide a succinct answer. 1.17. What is the ratio of the CO2 emissions (% of total fuel combustion) in OECD members in 1987 to that in 1994?
Give a very brief answer. 1.14. What is the ratio of the CO2 emissions (% of total fuel combustion) of World in 1987 to that in 1994?
Your response must be concise. 1.2. What is the ratio of the CO2 emissions (% of total fuel combustion) of Chile in 1987 to that in 1994?
Ensure brevity in your answer.  0.93. What is the ratio of the CO2 emissions (% of total fuel combustion) of Euro area in 1988 to that in 1989?
Offer a very short reply. 1.09. What is the ratio of the CO2 emissions (% of total fuel combustion) in OECD members in 1988 to that in 1989?
Ensure brevity in your answer.  1.05. What is the ratio of the CO2 emissions (% of total fuel combustion) of World in 1988 to that in 1989?
Your answer should be very brief. 1.04. What is the ratio of the CO2 emissions (% of total fuel combustion) in Chile in 1988 to that in 1989?
Offer a terse response. 1.13. What is the ratio of the CO2 emissions (% of total fuel combustion) of Euro area in 1988 to that in 1990?
Your answer should be compact. 1.07. What is the ratio of the CO2 emissions (% of total fuel combustion) of OECD members in 1988 to that in 1990?
Your answer should be very brief. 1.09. What is the ratio of the CO2 emissions (% of total fuel combustion) in World in 1988 to that in 1990?
Provide a succinct answer. 1.12. What is the ratio of the CO2 emissions (% of total fuel combustion) in Chile in 1988 to that in 1990?
Your answer should be compact. 0.96. What is the ratio of the CO2 emissions (% of total fuel combustion) in Euro area in 1988 to that in 1991?
Your answer should be very brief. 1.03. What is the ratio of the CO2 emissions (% of total fuel combustion) of OECD members in 1988 to that in 1991?
Ensure brevity in your answer.  1.07. What is the ratio of the CO2 emissions (% of total fuel combustion) of World in 1988 to that in 1991?
Your answer should be compact. 1.12. What is the ratio of the CO2 emissions (% of total fuel combustion) in Chile in 1988 to that in 1991?
Provide a succinct answer. 0.87. What is the ratio of the CO2 emissions (% of total fuel combustion) of Euro area in 1988 to that in 1992?
Ensure brevity in your answer.  1.07. What is the ratio of the CO2 emissions (% of total fuel combustion) of OECD members in 1988 to that in 1992?
Your response must be concise. 1.08. What is the ratio of the CO2 emissions (% of total fuel combustion) in World in 1988 to that in 1992?
Ensure brevity in your answer.  1.16. What is the ratio of the CO2 emissions (% of total fuel combustion) of Chile in 1988 to that in 1992?
Ensure brevity in your answer.  0.78. What is the ratio of the CO2 emissions (% of total fuel combustion) of Euro area in 1988 to that in 1993?
Make the answer very short. 1.04. What is the ratio of the CO2 emissions (% of total fuel combustion) in OECD members in 1988 to that in 1993?
Your response must be concise. 1.06. What is the ratio of the CO2 emissions (% of total fuel combustion) of World in 1988 to that in 1993?
Offer a very short reply. 1.14. What is the ratio of the CO2 emissions (% of total fuel combustion) of Chile in 1988 to that in 1993?
Ensure brevity in your answer.  0.79. What is the ratio of the CO2 emissions (% of total fuel combustion) in Euro area in 1988 to that in 1994?
Offer a very short reply. 1.11. What is the ratio of the CO2 emissions (% of total fuel combustion) in OECD members in 1988 to that in 1994?
Your answer should be very brief. 1.12. What is the ratio of the CO2 emissions (% of total fuel combustion) in World in 1988 to that in 1994?
Ensure brevity in your answer.  1.18. What is the ratio of the CO2 emissions (% of total fuel combustion) of Chile in 1988 to that in 1994?
Give a very brief answer. 0.83. What is the ratio of the CO2 emissions (% of total fuel combustion) of Euro area in 1989 to that in 1990?
Offer a very short reply. 0.99. What is the ratio of the CO2 emissions (% of total fuel combustion) in OECD members in 1989 to that in 1990?
Give a very brief answer. 1.04. What is the ratio of the CO2 emissions (% of total fuel combustion) of World in 1989 to that in 1990?
Make the answer very short. 1.07. What is the ratio of the CO2 emissions (% of total fuel combustion) of Chile in 1989 to that in 1990?
Your answer should be compact. 0.85. What is the ratio of the CO2 emissions (% of total fuel combustion) of Euro area in 1989 to that in 1991?
Your answer should be compact. 0.94. What is the ratio of the CO2 emissions (% of total fuel combustion) of OECD members in 1989 to that in 1991?
Provide a succinct answer. 1.02. What is the ratio of the CO2 emissions (% of total fuel combustion) of World in 1989 to that in 1991?
Offer a very short reply. 1.07. What is the ratio of the CO2 emissions (% of total fuel combustion) of Chile in 1989 to that in 1991?
Provide a short and direct response. 0.77. What is the ratio of the CO2 emissions (% of total fuel combustion) of Euro area in 1989 to that in 1992?
Make the answer very short. 0.98. What is the ratio of the CO2 emissions (% of total fuel combustion) of OECD members in 1989 to that in 1992?
Ensure brevity in your answer.  1.03. What is the ratio of the CO2 emissions (% of total fuel combustion) of World in 1989 to that in 1992?
Offer a terse response. 1.11. What is the ratio of the CO2 emissions (% of total fuel combustion) in Chile in 1989 to that in 1992?
Ensure brevity in your answer.  0.69. What is the ratio of the CO2 emissions (% of total fuel combustion) of Euro area in 1989 to that in 1993?
Your answer should be very brief. 0.96. What is the ratio of the CO2 emissions (% of total fuel combustion) of OECD members in 1989 to that in 1993?
Your answer should be compact. 1.01. What is the ratio of the CO2 emissions (% of total fuel combustion) in World in 1989 to that in 1993?
Offer a very short reply. 1.09. What is the ratio of the CO2 emissions (% of total fuel combustion) of Chile in 1989 to that in 1993?
Make the answer very short. 0.69. What is the ratio of the CO2 emissions (% of total fuel combustion) of Euro area in 1989 to that in 1994?
Your answer should be very brief. 1.02. What is the ratio of the CO2 emissions (% of total fuel combustion) in OECD members in 1989 to that in 1994?
Provide a succinct answer. 1.07. What is the ratio of the CO2 emissions (% of total fuel combustion) of World in 1989 to that in 1994?
Make the answer very short. 1.13. What is the ratio of the CO2 emissions (% of total fuel combustion) of Chile in 1989 to that in 1994?
Offer a very short reply. 0.73. What is the ratio of the CO2 emissions (% of total fuel combustion) in Euro area in 1990 to that in 1991?
Make the answer very short. 0.96. What is the ratio of the CO2 emissions (% of total fuel combustion) in OECD members in 1990 to that in 1991?
Offer a very short reply. 0.98. What is the ratio of the CO2 emissions (% of total fuel combustion) of World in 1990 to that in 1991?
Keep it short and to the point. 1. What is the ratio of the CO2 emissions (% of total fuel combustion) of Chile in 1990 to that in 1991?
Provide a succinct answer. 0.9. What is the ratio of the CO2 emissions (% of total fuel combustion) of Euro area in 1990 to that in 1992?
Make the answer very short. 1. What is the ratio of the CO2 emissions (% of total fuel combustion) of OECD members in 1990 to that in 1992?
Give a very brief answer. 0.99. What is the ratio of the CO2 emissions (% of total fuel combustion) of World in 1990 to that in 1992?
Your response must be concise. 1.03. What is the ratio of the CO2 emissions (% of total fuel combustion) in Chile in 1990 to that in 1992?
Give a very brief answer. 0.81. What is the ratio of the CO2 emissions (% of total fuel combustion) of Euro area in 1990 to that in 1993?
Your answer should be compact. 0.97. What is the ratio of the CO2 emissions (% of total fuel combustion) in World in 1990 to that in 1993?
Provide a short and direct response. 1.02. What is the ratio of the CO2 emissions (% of total fuel combustion) of Chile in 1990 to that in 1993?
Your response must be concise. 0.82. What is the ratio of the CO2 emissions (% of total fuel combustion) in Euro area in 1990 to that in 1994?
Provide a short and direct response. 1.03. What is the ratio of the CO2 emissions (% of total fuel combustion) of OECD members in 1990 to that in 1994?
Keep it short and to the point. 1.02. What is the ratio of the CO2 emissions (% of total fuel combustion) in World in 1990 to that in 1994?
Offer a terse response. 1.05. What is the ratio of the CO2 emissions (% of total fuel combustion) of Chile in 1990 to that in 1994?
Your answer should be very brief. 0.86. What is the ratio of the CO2 emissions (% of total fuel combustion) of Euro area in 1991 to that in 1992?
Your response must be concise. 1.04. What is the ratio of the CO2 emissions (% of total fuel combustion) in OECD members in 1991 to that in 1992?
Give a very brief answer. 1.02. What is the ratio of the CO2 emissions (% of total fuel combustion) of World in 1991 to that in 1992?
Give a very brief answer. 1.04. What is the ratio of the CO2 emissions (% of total fuel combustion) in Chile in 1991 to that in 1992?
Offer a very short reply. 0.89. What is the ratio of the CO2 emissions (% of total fuel combustion) in Euro area in 1991 to that in 1993?
Provide a succinct answer. 1.01. What is the ratio of the CO2 emissions (% of total fuel combustion) in Chile in 1991 to that in 1993?
Offer a terse response. 0.91. What is the ratio of the CO2 emissions (% of total fuel combustion) in Euro area in 1991 to that in 1994?
Keep it short and to the point. 1.08. What is the ratio of the CO2 emissions (% of total fuel combustion) of OECD members in 1991 to that in 1994?
Give a very brief answer. 1.05. What is the ratio of the CO2 emissions (% of total fuel combustion) of World in 1991 to that in 1994?
Your answer should be compact. 1.06. What is the ratio of the CO2 emissions (% of total fuel combustion) of Chile in 1991 to that in 1994?
Your answer should be compact. 0.96. What is the ratio of the CO2 emissions (% of total fuel combustion) in Euro area in 1992 to that in 1993?
Ensure brevity in your answer.  0.97. What is the ratio of the CO2 emissions (% of total fuel combustion) of World in 1992 to that in 1993?
Keep it short and to the point. 0.98. What is the ratio of the CO2 emissions (% of total fuel combustion) in Chile in 1992 to that in 1993?
Provide a succinct answer. 1.01. What is the ratio of the CO2 emissions (% of total fuel combustion) in Euro area in 1992 to that in 1994?
Ensure brevity in your answer.  1.04. What is the ratio of the CO2 emissions (% of total fuel combustion) in OECD members in 1992 to that in 1994?
Provide a short and direct response. 1.03. What is the ratio of the CO2 emissions (% of total fuel combustion) in World in 1992 to that in 1994?
Provide a short and direct response. 1.02. What is the ratio of the CO2 emissions (% of total fuel combustion) of Chile in 1992 to that in 1994?
Ensure brevity in your answer.  1.07. What is the ratio of the CO2 emissions (% of total fuel combustion) of Euro area in 1993 to that in 1994?
Your answer should be very brief. 1.07. What is the ratio of the CO2 emissions (% of total fuel combustion) of OECD members in 1993 to that in 1994?
Your response must be concise. 1.05. What is the ratio of the CO2 emissions (% of total fuel combustion) in World in 1993 to that in 1994?
Provide a short and direct response. 1.04. What is the ratio of the CO2 emissions (% of total fuel combustion) in Chile in 1993 to that in 1994?
Give a very brief answer. 1.05. What is the difference between the highest and the second highest CO2 emissions (% of total fuel combustion) of Euro area?
Offer a terse response. 1.14. What is the difference between the highest and the second highest CO2 emissions (% of total fuel combustion) of OECD members?
Provide a succinct answer. 0.31. What is the difference between the highest and the second highest CO2 emissions (% of total fuel combustion) of World?
Your answer should be very brief. 0.22. What is the difference between the highest and the second highest CO2 emissions (% of total fuel combustion) in Chile?
Give a very brief answer. 0.15. What is the difference between the highest and the lowest CO2 emissions (% of total fuel combustion) in Euro area?
Offer a terse response. 3.09. What is the difference between the highest and the lowest CO2 emissions (% of total fuel combustion) in OECD members?
Your answer should be very brief. 1.93. What is the difference between the highest and the lowest CO2 emissions (% of total fuel combustion) in World?
Your answer should be compact. 2.38. What is the difference between the highest and the lowest CO2 emissions (% of total fuel combustion) in Chile?
Provide a succinct answer. 3.72. 